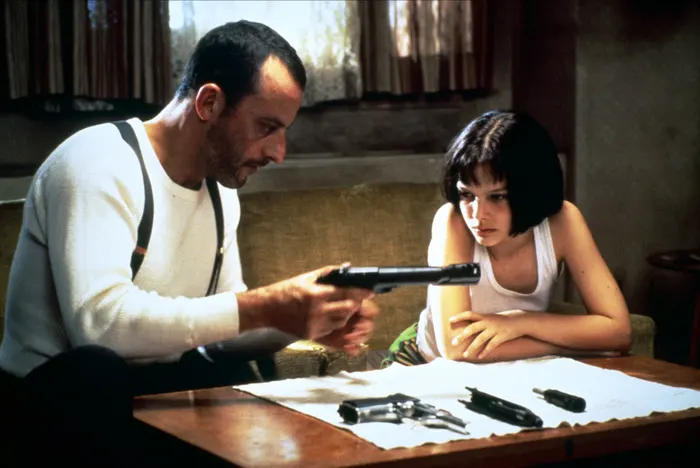What might the characters be discussing in this moment? In this scene, Léon is likely explaining the mechanics of the handgun to Mathilda, detailing its parts, functionality, and how to handle it responsibly. This moment underscores the gravity of Mathilda's training, moving from theory to practical application, an essential step in her transformation under Léon's tutelage. How does the setting influence the tone of the scene? The setting, a dimly lit room furnished sparingly with a simple wooden table and a subdued color palette, creates an intimate and tense atmosphere. It emphasizes the clandestine and dangerous nature of the world Léon inhabits, reinforcing the serious, almost somber tone of the training session. 